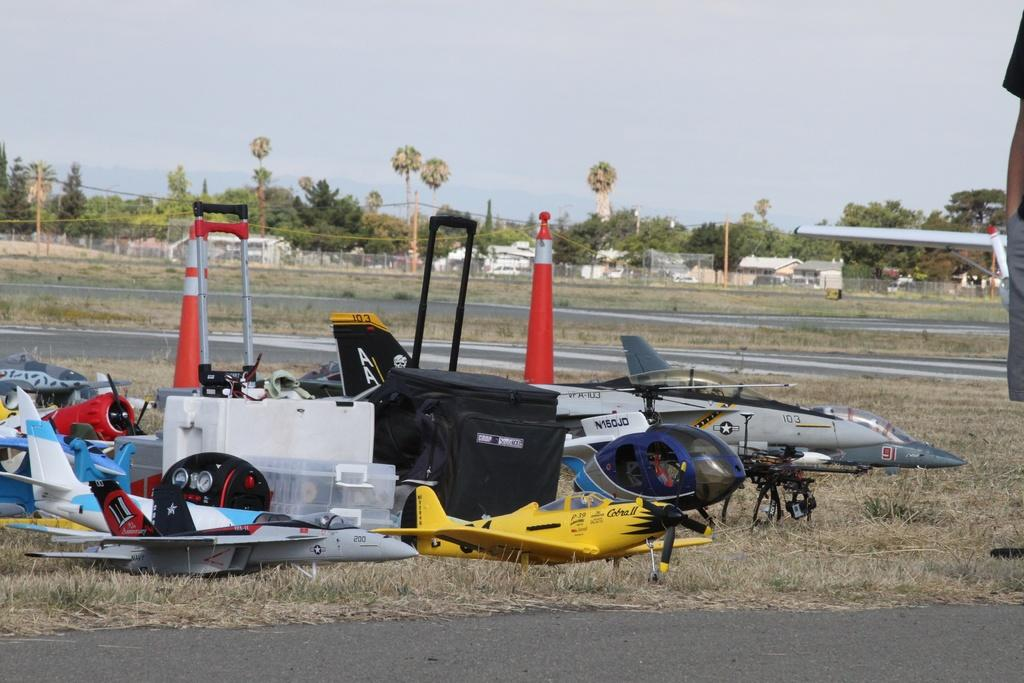Provide a one-sentence caption for the provided image. A collection of toy RC airplanes are laid out on the grass including the yellow Cobra II in the front. 